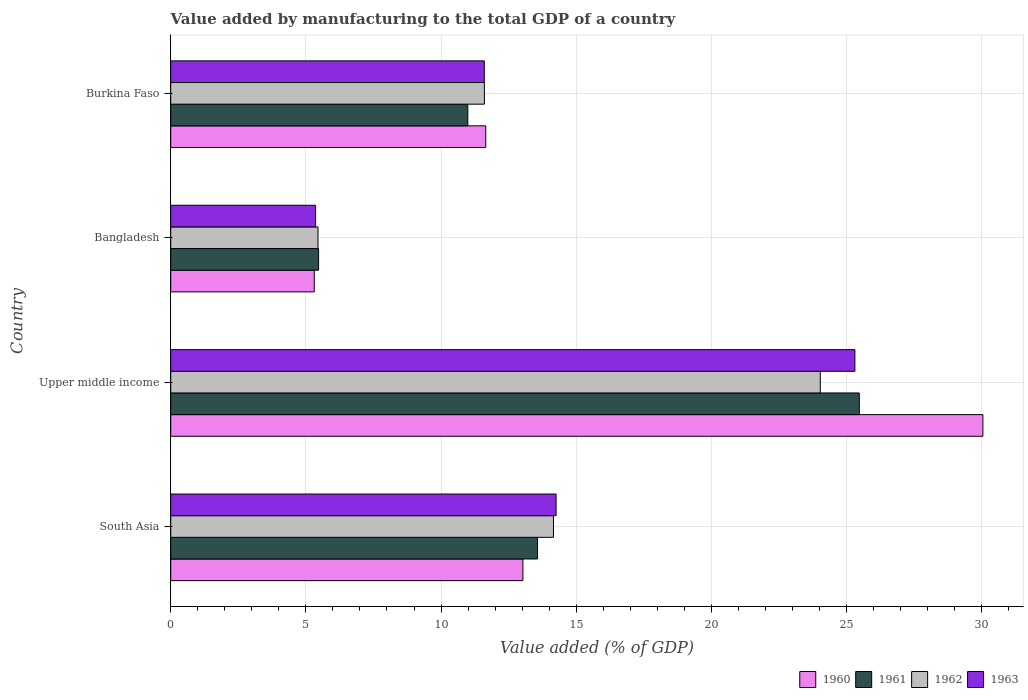How many different coloured bars are there?
Provide a short and direct response. 4. How many groups of bars are there?
Give a very brief answer. 4. Are the number of bars on each tick of the Y-axis equal?
Provide a succinct answer. Yes. How many bars are there on the 3rd tick from the top?
Your answer should be compact. 4. How many bars are there on the 4th tick from the bottom?
Ensure brevity in your answer.  4. In how many cases, is the number of bars for a given country not equal to the number of legend labels?
Give a very brief answer. 0. What is the value added by manufacturing to the total GDP in 1961 in Bangladesh?
Your answer should be very brief. 5.47. Across all countries, what is the maximum value added by manufacturing to the total GDP in 1961?
Offer a very short reply. 25.47. Across all countries, what is the minimum value added by manufacturing to the total GDP in 1963?
Provide a short and direct response. 5.36. In which country was the value added by manufacturing to the total GDP in 1960 maximum?
Provide a succinct answer. Upper middle income. What is the total value added by manufacturing to the total GDP in 1960 in the graph?
Your answer should be compact. 60.04. What is the difference between the value added by manufacturing to the total GDP in 1960 in Burkina Faso and that in Upper middle income?
Provide a short and direct response. -18.39. What is the difference between the value added by manufacturing to the total GDP in 1961 in Bangladesh and the value added by manufacturing to the total GDP in 1960 in Upper middle income?
Ensure brevity in your answer.  -24.57. What is the average value added by manufacturing to the total GDP in 1962 per country?
Make the answer very short. 13.81. What is the difference between the value added by manufacturing to the total GDP in 1963 and value added by manufacturing to the total GDP in 1960 in Bangladesh?
Keep it short and to the point. 0.05. What is the ratio of the value added by manufacturing to the total GDP in 1961 in Bangladesh to that in Burkina Faso?
Your response must be concise. 0.5. Is the value added by manufacturing to the total GDP in 1963 in Bangladesh less than that in Upper middle income?
Provide a short and direct response. Yes. Is the difference between the value added by manufacturing to the total GDP in 1963 in Bangladesh and Burkina Faso greater than the difference between the value added by manufacturing to the total GDP in 1960 in Bangladesh and Burkina Faso?
Offer a terse response. Yes. What is the difference between the highest and the second highest value added by manufacturing to the total GDP in 1962?
Make the answer very short. 9.87. What is the difference between the highest and the lowest value added by manufacturing to the total GDP in 1961?
Offer a terse response. 20. In how many countries, is the value added by manufacturing to the total GDP in 1961 greater than the average value added by manufacturing to the total GDP in 1961 taken over all countries?
Give a very brief answer. 1. Is the sum of the value added by manufacturing to the total GDP in 1962 in Bangladesh and Burkina Faso greater than the maximum value added by manufacturing to the total GDP in 1960 across all countries?
Offer a very short reply. No. Is it the case that in every country, the sum of the value added by manufacturing to the total GDP in 1961 and value added by manufacturing to the total GDP in 1962 is greater than the sum of value added by manufacturing to the total GDP in 1963 and value added by manufacturing to the total GDP in 1960?
Offer a terse response. No. What does the 2nd bar from the bottom in Burkina Faso represents?
Your answer should be very brief. 1961. Are all the bars in the graph horizontal?
Keep it short and to the point. Yes. Does the graph contain any zero values?
Your response must be concise. No. How are the legend labels stacked?
Give a very brief answer. Horizontal. What is the title of the graph?
Your answer should be compact. Value added by manufacturing to the total GDP of a country. Does "2003" appear as one of the legend labels in the graph?
Make the answer very short. No. What is the label or title of the X-axis?
Keep it short and to the point. Value added (% of GDP). What is the label or title of the Y-axis?
Ensure brevity in your answer.  Country. What is the Value added (% of GDP) in 1960 in South Asia?
Keep it short and to the point. 13.03. What is the Value added (% of GDP) of 1961 in South Asia?
Your answer should be very brief. 13.57. What is the Value added (% of GDP) of 1962 in South Asia?
Make the answer very short. 14.16. What is the Value added (% of GDP) in 1963 in South Asia?
Offer a very short reply. 14.26. What is the Value added (% of GDP) of 1960 in Upper middle income?
Your answer should be compact. 30.05. What is the Value added (% of GDP) in 1961 in Upper middle income?
Your answer should be very brief. 25.47. What is the Value added (% of GDP) in 1962 in Upper middle income?
Offer a terse response. 24.03. What is the Value added (% of GDP) of 1963 in Upper middle income?
Provide a succinct answer. 25.31. What is the Value added (% of GDP) of 1960 in Bangladesh?
Keep it short and to the point. 5.31. What is the Value added (% of GDP) of 1961 in Bangladesh?
Offer a terse response. 5.47. What is the Value added (% of GDP) in 1962 in Bangladesh?
Your response must be concise. 5.45. What is the Value added (% of GDP) of 1963 in Bangladesh?
Ensure brevity in your answer.  5.36. What is the Value added (% of GDP) of 1960 in Burkina Faso?
Make the answer very short. 11.65. What is the Value added (% of GDP) of 1961 in Burkina Faso?
Offer a terse response. 10.99. What is the Value added (% of GDP) of 1962 in Burkina Faso?
Your answer should be compact. 11.6. What is the Value added (% of GDP) of 1963 in Burkina Faso?
Ensure brevity in your answer.  11.6. Across all countries, what is the maximum Value added (% of GDP) in 1960?
Ensure brevity in your answer.  30.05. Across all countries, what is the maximum Value added (% of GDP) of 1961?
Make the answer very short. 25.47. Across all countries, what is the maximum Value added (% of GDP) in 1962?
Your response must be concise. 24.03. Across all countries, what is the maximum Value added (% of GDP) of 1963?
Make the answer very short. 25.31. Across all countries, what is the minimum Value added (% of GDP) of 1960?
Provide a short and direct response. 5.31. Across all countries, what is the minimum Value added (% of GDP) of 1961?
Your response must be concise. 5.47. Across all countries, what is the minimum Value added (% of GDP) in 1962?
Your answer should be compact. 5.45. Across all countries, what is the minimum Value added (% of GDP) in 1963?
Keep it short and to the point. 5.36. What is the total Value added (% of GDP) in 1960 in the graph?
Ensure brevity in your answer.  60.04. What is the total Value added (% of GDP) in 1961 in the graph?
Offer a very short reply. 55.51. What is the total Value added (% of GDP) of 1962 in the graph?
Offer a terse response. 55.24. What is the total Value added (% of GDP) of 1963 in the graph?
Your answer should be compact. 56.53. What is the difference between the Value added (% of GDP) in 1960 in South Asia and that in Upper middle income?
Make the answer very short. -17.02. What is the difference between the Value added (% of GDP) in 1961 in South Asia and that in Upper middle income?
Your response must be concise. -11.9. What is the difference between the Value added (% of GDP) in 1962 in South Asia and that in Upper middle income?
Your response must be concise. -9.87. What is the difference between the Value added (% of GDP) of 1963 in South Asia and that in Upper middle income?
Your response must be concise. -11.05. What is the difference between the Value added (% of GDP) of 1960 in South Asia and that in Bangladesh?
Provide a short and direct response. 7.72. What is the difference between the Value added (% of GDP) in 1961 in South Asia and that in Bangladesh?
Keep it short and to the point. 8.1. What is the difference between the Value added (% of GDP) in 1962 in South Asia and that in Bangladesh?
Your answer should be very brief. 8.71. What is the difference between the Value added (% of GDP) of 1963 in South Asia and that in Bangladesh?
Make the answer very short. 8.9. What is the difference between the Value added (% of GDP) in 1960 in South Asia and that in Burkina Faso?
Keep it short and to the point. 1.37. What is the difference between the Value added (% of GDP) of 1961 in South Asia and that in Burkina Faso?
Provide a short and direct response. 2.58. What is the difference between the Value added (% of GDP) of 1962 in South Asia and that in Burkina Faso?
Provide a short and direct response. 2.56. What is the difference between the Value added (% of GDP) of 1963 in South Asia and that in Burkina Faso?
Your response must be concise. 2.66. What is the difference between the Value added (% of GDP) in 1960 in Upper middle income and that in Bangladesh?
Give a very brief answer. 24.74. What is the difference between the Value added (% of GDP) of 1961 in Upper middle income and that in Bangladesh?
Your answer should be compact. 20. What is the difference between the Value added (% of GDP) in 1962 in Upper middle income and that in Bangladesh?
Make the answer very short. 18.58. What is the difference between the Value added (% of GDP) in 1963 in Upper middle income and that in Bangladesh?
Offer a very short reply. 19.95. What is the difference between the Value added (% of GDP) of 1960 in Upper middle income and that in Burkina Faso?
Offer a terse response. 18.39. What is the difference between the Value added (% of GDP) of 1961 in Upper middle income and that in Burkina Faso?
Your answer should be very brief. 14.48. What is the difference between the Value added (% of GDP) of 1962 in Upper middle income and that in Burkina Faso?
Keep it short and to the point. 12.43. What is the difference between the Value added (% of GDP) in 1963 in Upper middle income and that in Burkina Faso?
Provide a succinct answer. 13.71. What is the difference between the Value added (% of GDP) in 1960 in Bangladesh and that in Burkina Faso?
Give a very brief answer. -6.34. What is the difference between the Value added (% of GDP) in 1961 in Bangladesh and that in Burkina Faso?
Ensure brevity in your answer.  -5.52. What is the difference between the Value added (% of GDP) in 1962 in Bangladesh and that in Burkina Faso?
Your response must be concise. -6.16. What is the difference between the Value added (% of GDP) of 1963 in Bangladesh and that in Burkina Faso?
Provide a succinct answer. -6.24. What is the difference between the Value added (% of GDP) of 1960 in South Asia and the Value added (% of GDP) of 1961 in Upper middle income?
Keep it short and to the point. -12.44. What is the difference between the Value added (% of GDP) of 1960 in South Asia and the Value added (% of GDP) of 1962 in Upper middle income?
Make the answer very short. -11. What is the difference between the Value added (% of GDP) in 1960 in South Asia and the Value added (% of GDP) in 1963 in Upper middle income?
Your answer should be very brief. -12.28. What is the difference between the Value added (% of GDP) in 1961 in South Asia and the Value added (% of GDP) in 1962 in Upper middle income?
Offer a very short reply. -10.46. What is the difference between the Value added (% of GDP) of 1961 in South Asia and the Value added (% of GDP) of 1963 in Upper middle income?
Provide a short and direct response. -11.74. What is the difference between the Value added (% of GDP) of 1962 in South Asia and the Value added (% of GDP) of 1963 in Upper middle income?
Offer a very short reply. -11.15. What is the difference between the Value added (% of GDP) in 1960 in South Asia and the Value added (% of GDP) in 1961 in Bangladesh?
Give a very brief answer. 7.56. What is the difference between the Value added (% of GDP) of 1960 in South Asia and the Value added (% of GDP) of 1962 in Bangladesh?
Your answer should be compact. 7.58. What is the difference between the Value added (% of GDP) in 1960 in South Asia and the Value added (% of GDP) in 1963 in Bangladesh?
Keep it short and to the point. 7.67. What is the difference between the Value added (% of GDP) of 1961 in South Asia and the Value added (% of GDP) of 1962 in Bangladesh?
Make the answer very short. 8.12. What is the difference between the Value added (% of GDP) of 1961 in South Asia and the Value added (% of GDP) of 1963 in Bangladesh?
Provide a succinct answer. 8.21. What is the difference between the Value added (% of GDP) of 1962 in South Asia and the Value added (% of GDP) of 1963 in Bangladesh?
Provide a succinct answer. 8.8. What is the difference between the Value added (% of GDP) of 1960 in South Asia and the Value added (% of GDP) of 1961 in Burkina Faso?
Offer a very short reply. 2.04. What is the difference between the Value added (% of GDP) in 1960 in South Asia and the Value added (% of GDP) in 1962 in Burkina Faso?
Ensure brevity in your answer.  1.43. What is the difference between the Value added (% of GDP) of 1960 in South Asia and the Value added (% of GDP) of 1963 in Burkina Faso?
Provide a succinct answer. 1.43. What is the difference between the Value added (% of GDP) of 1961 in South Asia and the Value added (% of GDP) of 1962 in Burkina Faso?
Your answer should be very brief. 1.97. What is the difference between the Value added (% of GDP) of 1961 in South Asia and the Value added (% of GDP) of 1963 in Burkina Faso?
Make the answer very short. 1.97. What is the difference between the Value added (% of GDP) of 1962 in South Asia and the Value added (% of GDP) of 1963 in Burkina Faso?
Ensure brevity in your answer.  2.56. What is the difference between the Value added (% of GDP) of 1960 in Upper middle income and the Value added (% of GDP) of 1961 in Bangladesh?
Provide a succinct answer. 24.57. What is the difference between the Value added (% of GDP) of 1960 in Upper middle income and the Value added (% of GDP) of 1962 in Bangladesh?
Keep it short and to the point. 24.6. What is the difference between the Value added (% of GDP) in 1960 in Upper middle income and the Value added (% of GDP) in 1963 in Bangladesh?
Give a very brief answer. 24.69. What is the difference between the Value added (% of GDP) of 1961 in Upper middle income and the Value added (% of GDP) of 1962 in Bangladesh?
Offer a very short reply. 20.03. What is the difference between the Value added (% of GDP) in 1961 in Upper middle income and the Value added (% of GDP) in 1963 in Bangladesh?
Offer a very short reply. 20.11. What is the difference between the Value added (% of GDP) in 1962 in Upper middle income and the Value added (% of GDP) in 1963 in Bangladesh?
Offer a terse response. 18.67. What is the difference between the Value added (% of GDP) in 1960 in Upper middle income and the Value added (% of GDP) in 1961 in Burkina Faso?
Offer a very short reply. 19.05. What is the difference between the Value added (% of GDP) in 1960 in Upper middle income and the Value added (% of GDP) in 1962 in Burkina Faso?
Offer a very short reply. 18.44. What is the difference between the Value added (% of GDP) of 1960 in Upper middle income and the Value added (% of GDP) of 1963 in Burkina Faso?
Offer a terse response. 18.44. What is the difference between the Value added (% of GDP) in 1961 in Upper middle income and the Value added (% of GDP) in 1962 in Burkina Faso?
Make the answer very short. 13.87. What is the difference between the Value added (% of GDP) of 1961 in Upper middle income and the Value added (% of GDP) of 1963 in Burkina Faso?
Keep it short and to the point. 13.87. What is the difference between the Value added (% of GDP) of 1962 in Upper middle income and the Value added (% of GDP) of 1963 in Burkina Faso?
Offer a terse response. 12.43. What is the difference between the Value added (% of GDP) in 1960 in Bangladesh and the Value added (% of GDP) in 1961 in Burkina Faso?
Ensure brevity in your answer.  -5.68. What is the difference between the Value added (% of GDP) in 1960 in Bangladesh and the Value added (% of GDP) in 1962 in Burkina Faso?
Ensure brevity in your answer.  -6.29. What is the difference between the Value added (% of GDP) of 1960 in Bangladesh and the Value added (% of GDP) of 1963 in Burkina Faso?
Your response must be concise. -6.29. What is the difference between the Value added (% of GDP) in 1961 in Bangladesh and the Value added (% of GDP) in 1962 in Burkina Faso?
Your answer should be very brief. -6.13. What is the difference between the Value added (% of GDP) of 1961 in Bangladesh and the Value added (% of GDP) of 1963 in Burkina Faso?
Provide a succinct answer. -6.13. What is the difference between the Value added (% of GDP) of 1962 in Bangladesh and the Value added (% of GDP) of 1963 in Burkina Faso?
Offer a very short reply. -6.15. What is the average Value added (% of GDP) of 1960 per country?
Offer a very short reply. 15.01. What is the average Value added (% of GDP) in 1961 per country?
Your answer should be compact. 13.88. What is the average Value added (% of GDP) of 1962 per country?
Offer a very short reply. 13.81. What is the average Value added (% of GDP) of 1963 per country?
Ensure brevity in your answer.  14.13. What is the difference between the Value added (% of GDP) in 1960 and Value added (% of GDP) in 1961 in South Asia?
Offer a very short reply. -0.54. What is the difference between the Value added (% of GDP) of 1960 and Value added (% of GDP) of 1962 in South Asia?
Give a very brief answer. -1.13. What is the difference between the Value added (% of GDP) of 1960 and Value added (% of GDP) of 1963 in South Asia?
Give a very brief answer. -1.23. What is the difference between the Value added (% of GDP) of 1961 and Value added (% of GDP) of 1962 in South Asia?
Make the answer very short. -0.59. What is the difference between the Value added (% of GDP) of 1961 and Value added (% of GDP) of 1963 in South Asia?
Your answer should be compact. -0.69. What is the difference between the Value added (% of GDP) in 1962 and Value added (% of GDP) in 1963 in South Asia?
Provide a short and direct response. -0.1. What is the difference between the Value added (% of GDP) in 1960 and Value added (% of GDP) in 1961 in Upper middle income?
Offer a very short reply. 4.57. What is the difference between the Value added (% of GDP) of 1960 and Value added (% of GDP) of 1962 in Upper middle income?
Your answer should be compact. 6.01. What is the difference between the Value added (% of GDP) of 1960 and Value added (% of GDP) of 1963 in Upper middle income?
Provide a short and direct response. 4.73. What is the difference between the Value added (% of GDP) in 1961 and Value added (% of GDP) in 1962 in Upper middle income?
Offer a very short reply. 1.44. What is the difference between the Value added (% of GDP) in 1961 and Value added (% of GDP) in 1963 in Upper middle income?
Give a very brief answer. 0.16. What is the difference between the Value added (% of GDP) in 1962 and Value added (% of GDP) in 1963 in Upper middle income?
Your response must be concise. -1.28. What is the difference between the Value added (% of GDP) in 1960 and Value added (% of GDP) in 1961 in Bangladesh?
Provide a succinct answer. -0.16. What is the difference between the Value added (% of GDP) in 1960 and Value added (% of GDP) in 1962 in Bangladesh?
Offer a very short reply. -0.14. What is the difference between the Value added (% of GDP) in 1960 and Value added (% of GDP) in 1963 in Bangladesh?
Provide a succinct answer. -0.05. What is the difference between the Value added (% of GDP) of 1961 and Value added (% of GDP) of 1962 in Bangladesh?
Provide a succinct answer. 0.02. What is the difference between the Value added (% of GDP) of 1961 and Value added (% of GDP) of 1963 in Bangladesh?
Offer a terse response. 0.11. What is the difference between the Value added (% of GDP) in 1962 and Value added (% of GDP) in 1963 in Bangladesh?
Your response must be concise. 0.09. What is the difference between the Value added (% of GDP) in 1960 and Value added (% of GDP) in 1961 in Burkina Faso?
Give a very brief answer. 0.66. What is the difference between the Value added (% of GDP) of 1960 and Value added (% of GDP) of 1962 in Burkina Faso?
Provide a succinct answer. 0.05. What is the difference between the Value added (% of GDP) of 1960 and Value added (% of GDP) of 1963 in Burkina Faso?
Give a very brief answer. 0.05. What is the difference between the Value added (% of GDP) of 1961 and Value added (% of GDP) of 1962 in Burkina Faso?
Keep it short and to the point. -0.61. What is the difference between the Value added (% of GDP) in 1961 and Value added (% of GDP) in 1963 in Burkina Faso?
Make the answer very short. -0.61. What is the difference between the Value added (% of GDP) in 1962 and Value added (% of GDP) in 1963 in Burkina Faso?
Offer a very short reply. 0. What is the ratio of the Value added (% of GDP) of 1960 in South Asia to that in Upper middle income?
Your answer should be compact. 0.43. What is the ratio of the Value added (% of GDP) of 1961 in South Asia to that in Upper middle income?
Keep it short and to the point. 0.53. What is the ratio of the Value added (% of GDP) of 1962 in South Asia to that in Upper middle income?
Ensure brevity in your answer.  0.59. What is the ratio of the Value added (% of GDP) of 1963 in South Asia to that in Upper middle income?
Your response must be concise. 0.56. What is the ratio of the Value added (% of GDP) of 1960 in South Asia to that in Bangladesh?
Give a very brief answer. 2.45. What is the ratio of the Value added (% of GDP) of 1961 in South Asia to that in Bangladesh?
Ensure brevity in your answer.  2.48. What is the ratio of the Value added (% of GDP) in 1962 in South Asia to that in Bangladesh?
Keep it short and to the point. 2.6. What is the ratio of the Value added (% of GDP) of 1963 in South Asia to that in Bangladesh?
Your response must be concise. 2.66. What is the ratio of the Value added (% of GDP) in 1960 in South Asia to that in Burkina Faso?
Your answer should be very brief. 1.12. What is the ratio of the Value added (% of GDP) of 1961 in South Asia to that in Burkina Faso?
Keep it short and to the point. 1.23. What is the ratio of the Value added (% of GDP) in 1962 in South Asia to that in Burkina Faso?
Offer a terse response. 1.22. What is the ratio of the Value added (% of GDP) in 1963 in South Asia to that in Burkina Faso?
Your response must be concise. 1.23. What is the ratio of the Value added (% of GDP) of 1960 in Upper middle income to that in Bangladesh?
Keep it short and to the point. 5.66. What is the ratio of the Value added (% of GDP) in 1961 in Upper middle income to that in Bangladesh?
Your answer should be compact. 4.66. What is the ratio of the Value added (% of GDP) in 1962 in Upper middle income to that in Bangladesh?
Your response must be concise. 4.41. What is the ratio of the Value added (% of GDP) of 1963 in Upper middle income to that in Bangladesh?
Your answer should be compact. 4.72. What is the ratio of the Value added (% of GDP) of 1960 in Upper middle income to that in Burkina Faso?
Offer a very short reply. 2.58. What is the ratio of the Value added (% of GDP) of 1961 in Upper middle income to that in Burkina Faso?
Your response must be concise. 2.32. What is the ratio of the Value added (% of GDP) in 1962 in Upper middle income to that in Burkina Faso?
Offer a terse response. 2.07. What is the ratio of the Value added (% of GDP) of 1963 in Upper middle income to that in Burkina Faso?
Offer a terse response. 2.18. What is the ratio of the Value added (% of GDP) of 1960 in Bangladesh to that in Burkina Faso?
Give a very brief answer. 0.46. What is the ratio of the Value added (% of GDP) of 1961 in Bangladesh to that in Burkina Faso?
Offer a very short reply. 0.5. What is the ratio of the Value added (% of GDP) of 1962 in Bangladesh to that in Burkina Faso?
Offer a terse response. 0.47. What is the ratio of the Value added (% of GDP) in 1963 in Bangladesh to that in Burkina Faso?
Your response must be concise. 0.46. What is the difference between the highest and the second highest Value added (% of GDP) of 1960?
Ensure brevity in your answer.  17.02. What is the difference between the highest and the second highest Value added (% of GDP) of 1961?
Make the answer very short. 11.9. What is the difference between the highest and the second highest Value added (% of GDP) in 1962?
Provide a short and direct response. 9.87. What is the difference between the highest and the second highest Value added (% of GDP) in 1963?
Ensure brevity in your answer.  11.05. What is the difference between the highest and the lowest Value added (% of GDP) of 1960?
Your answer should be very brief. 24.74. What is the difference between the highest and the lowest Value added (% of GDP) of 1961?
Your response must be concise. 20. What is the difference between the highest and the lowest Value added (% of GDP) in 1962?
Make the answer very short. 18.58. What is the difference between the highest and the lowest Value added (% of GDP) in 1963?
Offer a very short reply. 19.95. 